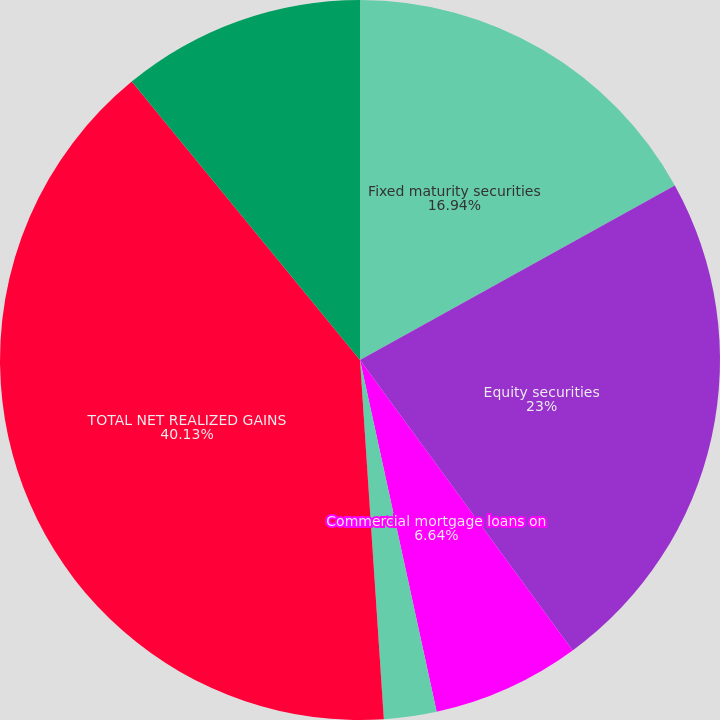<chart> <loc_0><loc_0><loc_500><loc_500><pie_chart><fcel>Fixed maturity securities<fcel>Equity securities<fcel>Commercial mortgage loans on<fcel>Other investments<fcel>TOTAL NET REALIZED GAINS<fcel>Total net realized losses<nl><fcel>16.94%<fcel>23.0%<fcel>6.64%<fcel>2.36%<fcel>40.12%<fcel>10.93%<nl></chart> 